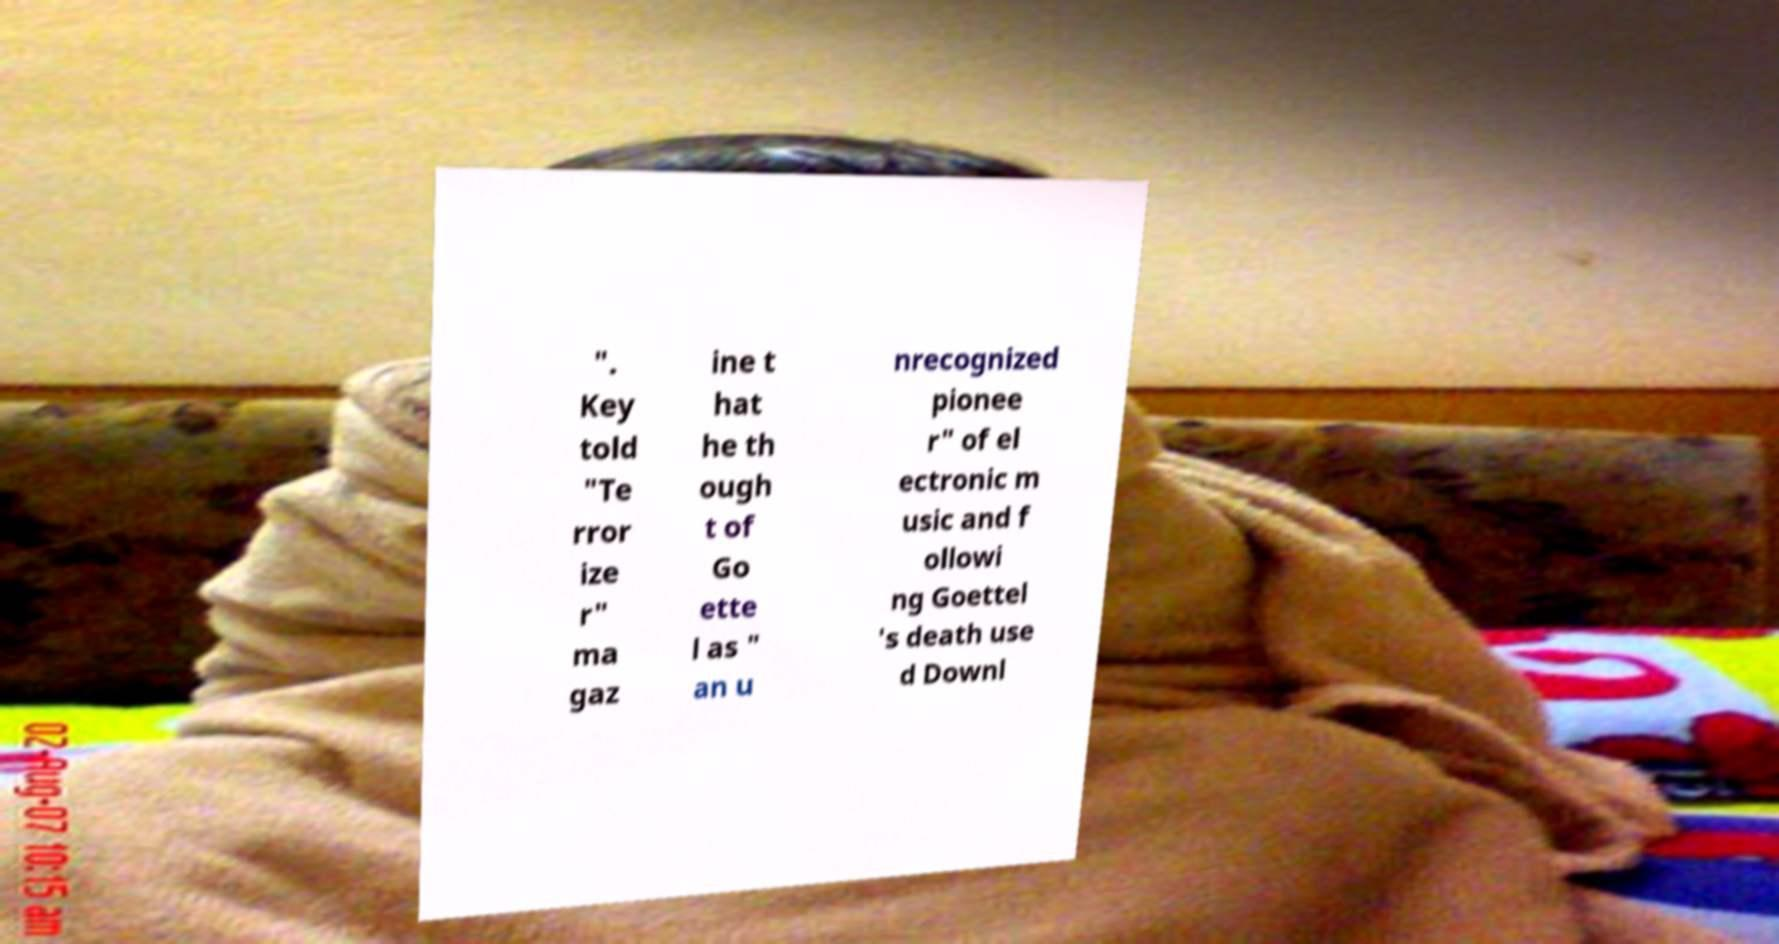What messages or text are displayed in this image? I need them in a readable, typed format. ". Key told "Te rror ize r" ma gaz ine t hat he th ough t of Go ette l as " an u nrecognized pionee r" of el ectronic m usic and f ollowi ng Goettel 's death use d Downl 